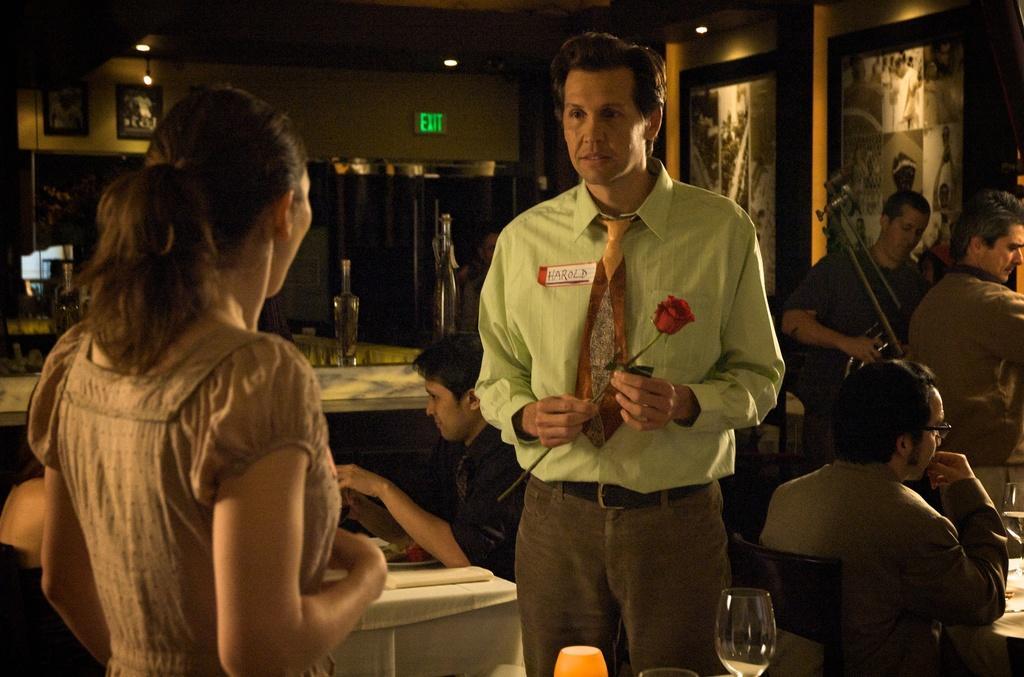Describe this image in one or two sentences. In this image I can see number of people were few of them are standing and few of them are sitting. I can also see few glasses and few frames on this wall. 